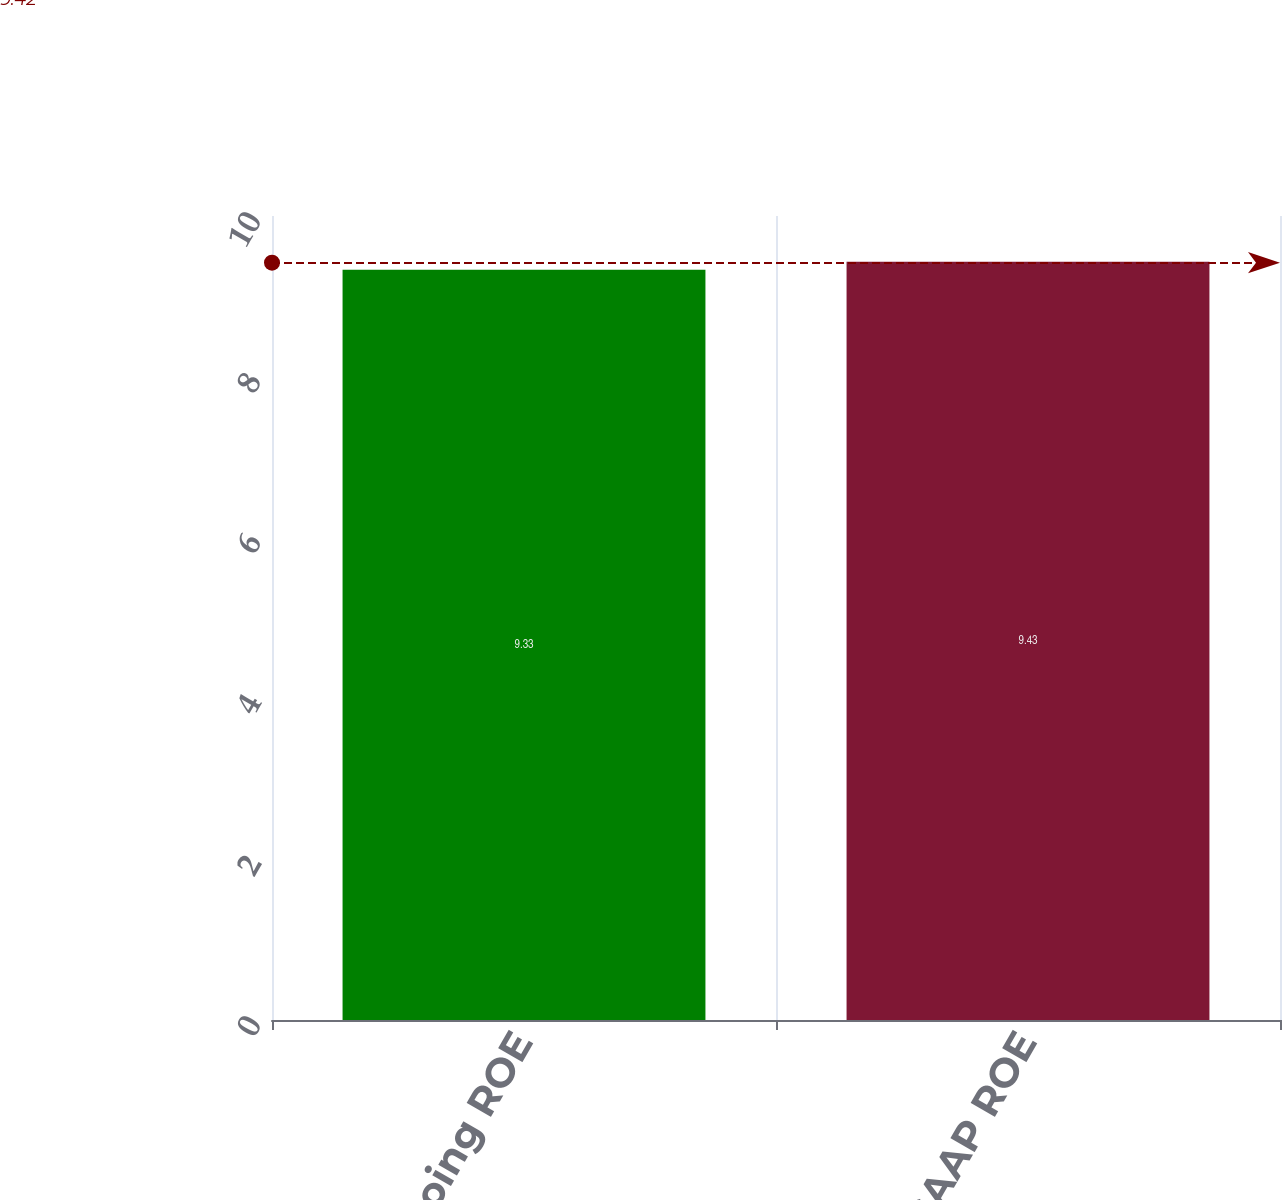<chart> <loc_0><loc_0><loc_500><loc_500><bar_chart><fcel>2015 ongoing ROE<fcel>2015 GAAP ROE<nl><fcel>9.33<fcel>9.43<nl></chart> 